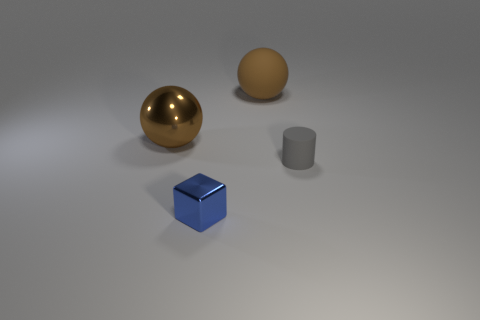Add 4 rubber spheres. How many objects exist? 8 Subtract 1 blocks. How many blocks are left? 0 Subtract all cubes. How many objects are left? 3 Subtract all gray blocks. Subtract all brown spheres. How many blocks are left? 1 Add 4 cylinders. How many cylinders exist? 5 Subtract 0 yellow cubes. How many objects are left? 4 Subtract all blue metal cubes. Subtract all gray cylinders. How many objects are left? 2 Add 1 blue things. How many blue things are left? 2 